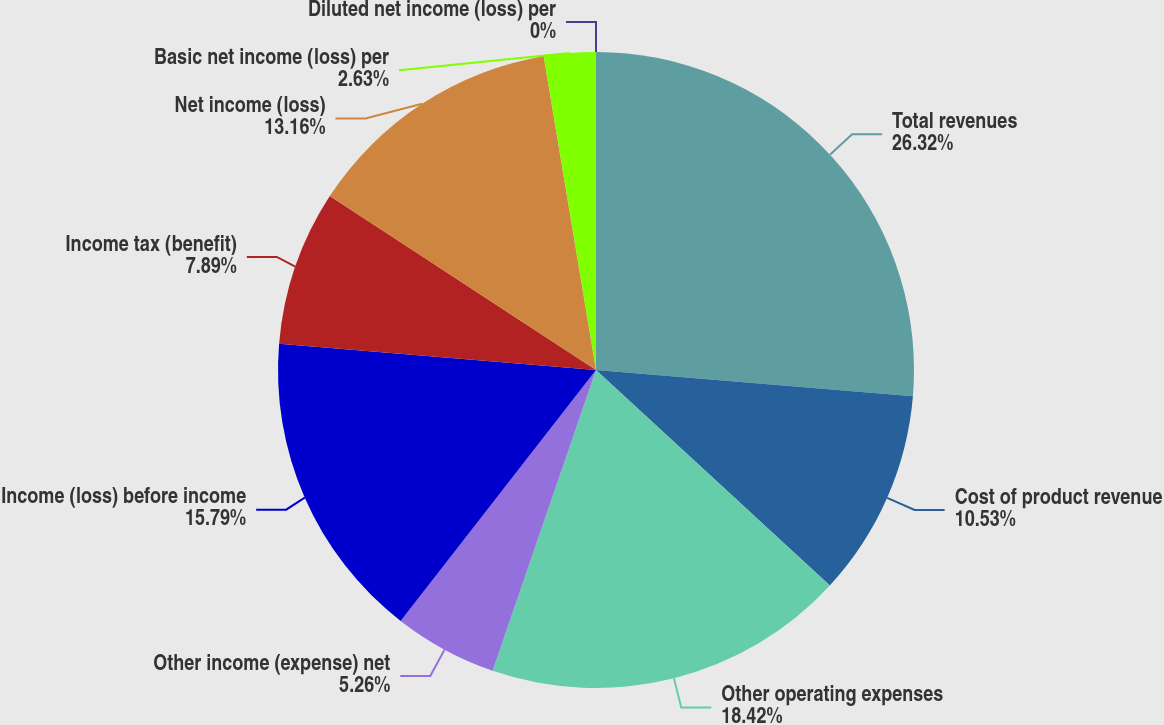<chart> <loc_0><loc_0><loc_500><loc_500><pie_chart><fcel>Total revenues<fcel>Cost of product revenue<fcel>Other operating expenses<fcel>Other income (expense) net<fcel>Income (loss) before income<fcel>Income tax (benefit)<fcel>Net income (loss)<fcel>Basic net income (loss) per<fcel>Diluted net income (loss) per<nl><fcel>26.32%<fcel>10.53%<fcel>18.42%<fcel>5.26%<fcel>15.79%<fcel>7.89%<fcel>13.16%<fcel>2.63%<fcel>0.0%<nl></chart> 